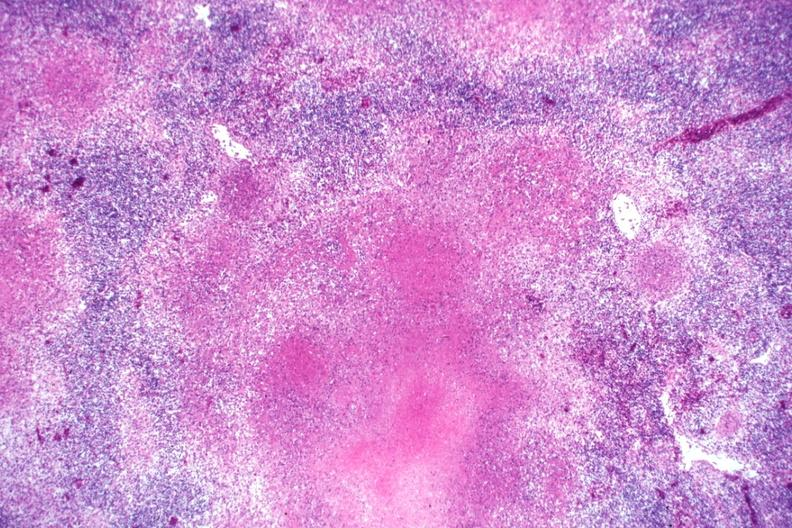s tuberculosis present?
Answer the question using a single word or phrase. Yes 